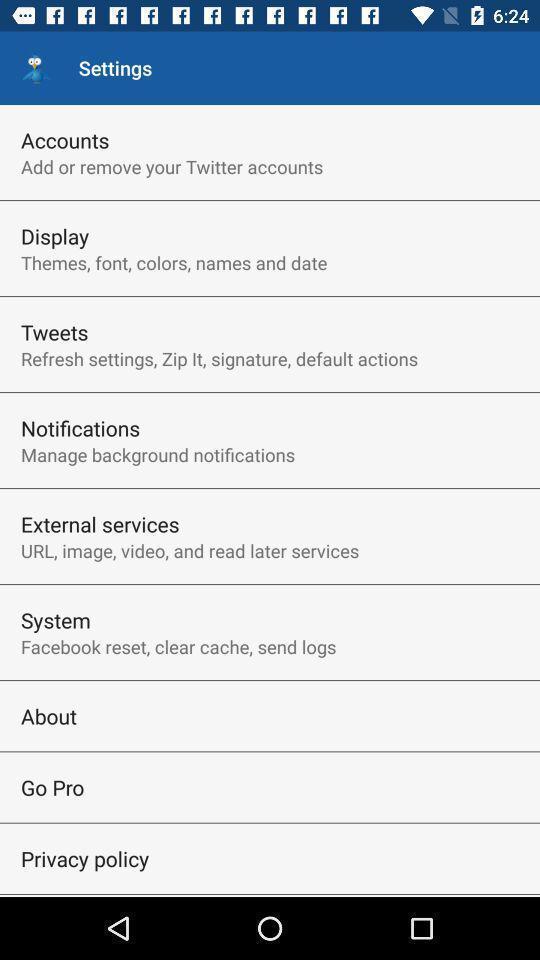Provide a detailed account of this screenshot. Settings page in a social app. 